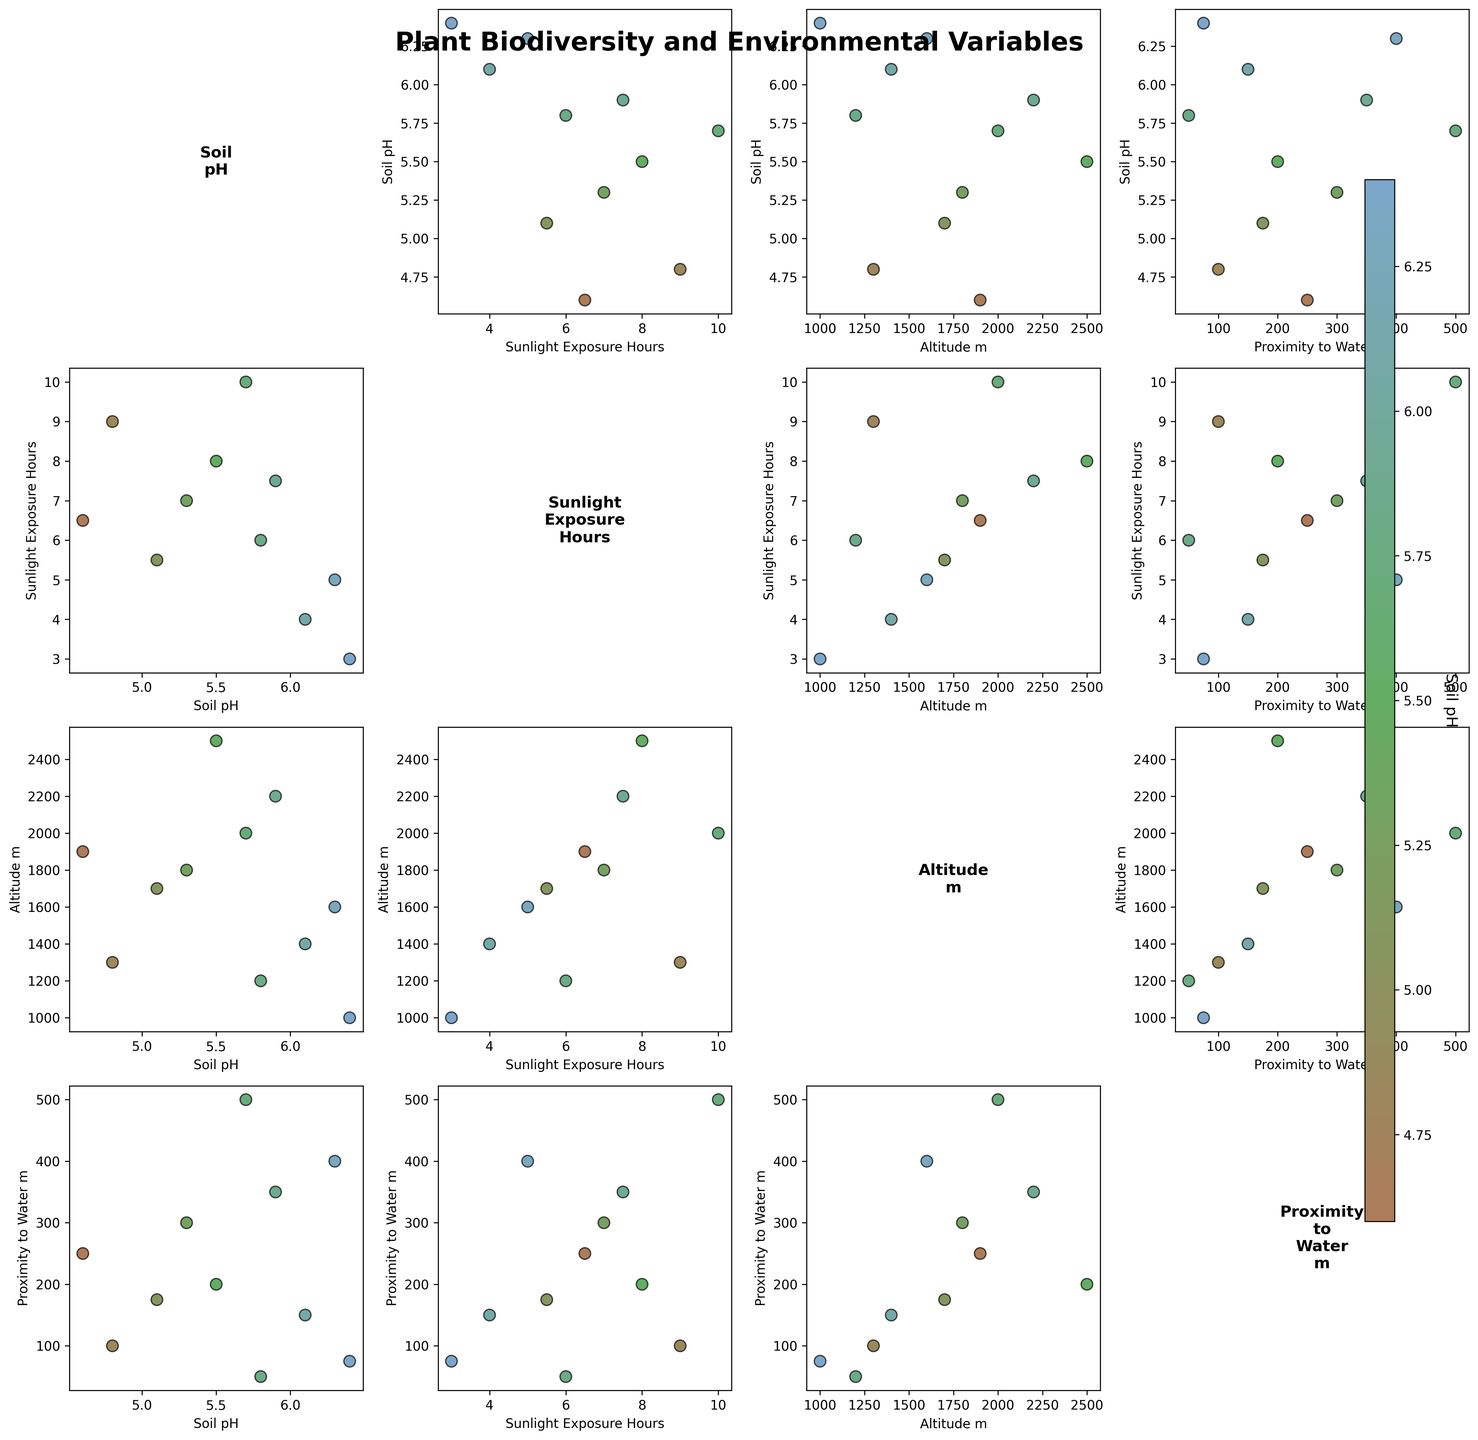What is the title of the figure? The title is usually displayed at the top of the figure. Here, it mentions the focus on plant biodiversity and environmental variables.
Answer: Plant Biodiversity and Environmental Variables How many data points have a Soil pH value greater than 6.0? By looking at the points' color bar, any color towards the right of 6.0 on the Soil pH scale will count. We count the number of such points in the scatter plots.
Answer: 4 Which environmental variable shows the clearest separation based on Soil pH values? By examining the scatter plots and the color gradient for Soil pH, the variable with the most distinct clusters or separation will be most apparent.
Answer: Altitude Is there any visible clustering of plant species based on Sunlight Exposure Hours? Look for any groupings of points along the x-axis of the Sunlight Exposure Hours plots and note if certain Soil pH ranges dominate in specific areas.
Answer: No clear clustering What combination of environmental variables has the lowest range in their values? Compare the ranges of values in the scatter plots. Look for the smallest spread along both axes across different pairs of variables.
Answer: Proximity to Water and Soil pH Do plants closer to water (Proximity to Water) tend to have higher or lower Soil pH? Examine the scatter plots where Proximity to Water_m is plotted against Soil pH and look for the general trend or slope.
Answer: Lower Does Altitude appear to have a relationship with Sunlight Exposure? Look at the scatter plot between Altitude and Sunlight Exposure Hours for any noticeable trend or correlation.
Answer: Slight positive correlation Which environmental variable has the widest range across the data points? Compare the ranges across all scatter plots by observing the spreads along the axes for each environmental variable. The widest span will indicate the variable.
Answer: Altitude Are there any data points that have high Altitude but are close to water? Inspect the specific scatter plot of Altitude_m vs Proximity_to_Water_m for points in the upper range of Altitude but lower range of Proximity to Water.
Answer: No Which plant species is found at the lowest altitude? Identify the points with the lowest y-values in the Altitude_m scatter plots and check their labels.
Answer: Umbellularia californica 